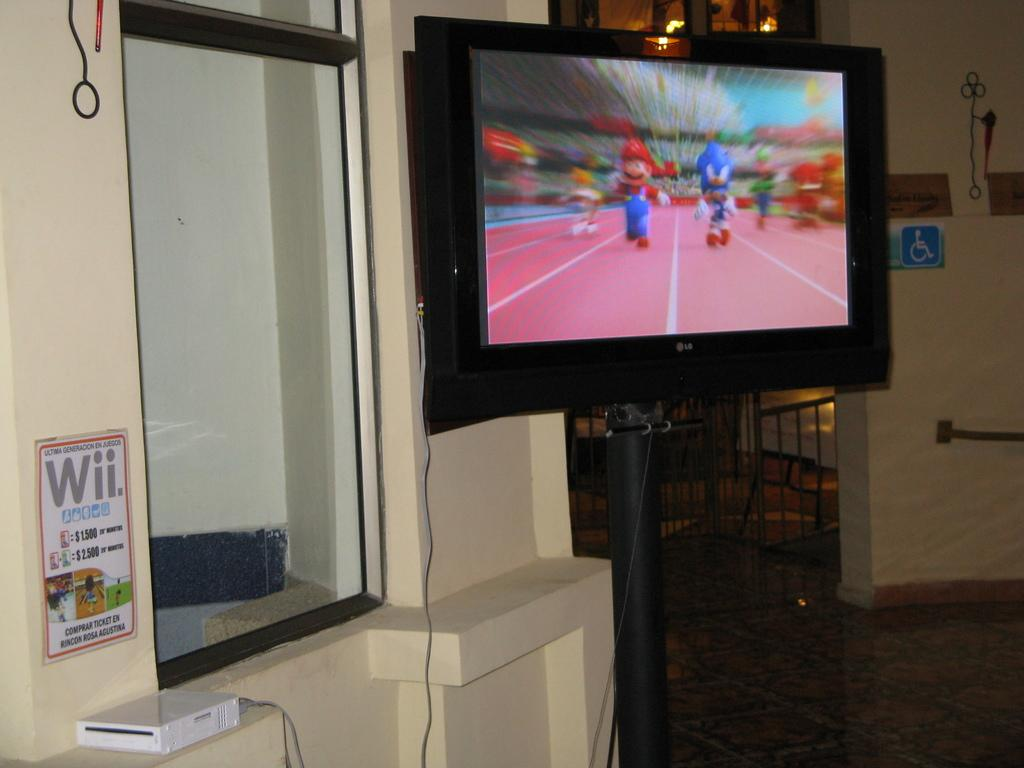Provide a one-sentence caption for the provided image. A Nintendo Wii connected to a flat screen television in a public area. 